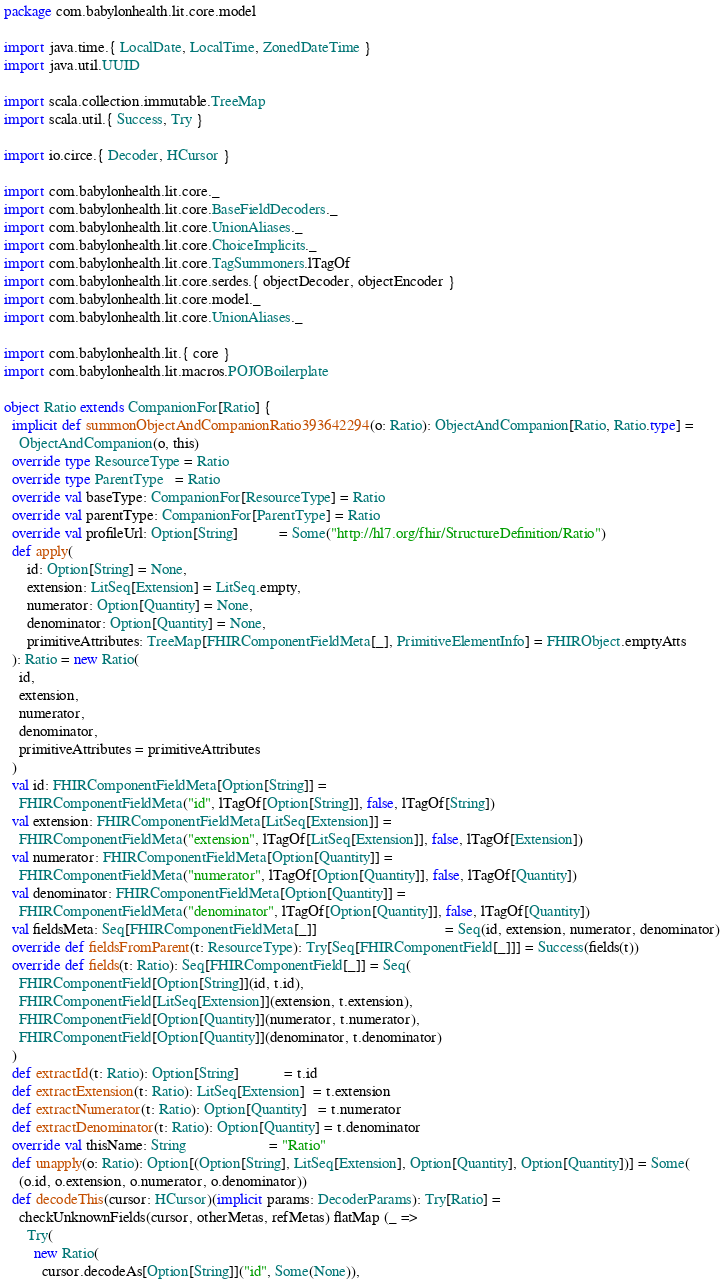Convert code to text. <code><loc_0><loc_0><loc_500><loc_500><_Scala_>package com.babylonhealth.lit.core.model

import java.time.{ LocalDate, LocalTime, ZonedDateTime }
import java.util.UUID

import scala.collection.immutable.TreeMap
import scala.util.{ Success, Try }

import io.circe.{ Decoder, HCursor }

import com.babylonhealth.lit.core._
import com.babylonhealth.lit.core.BaseFieldDecoders._
import com.babylonhealth.lit.core.UnionAliases._
import com.babylonhealth.lit.core.ChoiceImplicits._
import com.babylonhealth.lit.core.TagSummoners.lTagOf
import com.babylonhealth.lit.core.serdes.{ objectDecoder, objectEncoder }
import com.babylonhealth.lit.core.model._
import com.babylonhealth.lit.core.UnionAliases._

import com.babylonhealth.lit.{ core }
import com.babylonhealth.lit.macros.POJOBoilerplate

object Ratio extends CompanionFor[Ratio] {
  implicit def summonObjectAndCompanionRatio393642294(o: Ratio): ObjectAndCompanion[Ratio, Ratio.type] =
    ObjectAndCompanion(o, this)
  override type ResourceType = Ratio
  override type ParentType   = Ratio
  override val baseType: CompanionFor[ResourceType] = Ratio
  override val parentType: CompanionFor[ParentType] = Ratio
  override val profileUrl: Option[String]           = Some("http://hl7.org/fhir/StructureDefinition/Ratio")
  def apply(
      id: Option[String] = None,
      extension: LitSeq[Extension] = LitSeq.empty,
      numerator: Option[Quantity] = None,
      denominator: Option[Quantity] = None,
      primitiveAttributes: TreeMap[FHIRComponentFieldMeta[_], PrimitiveElementInfo] = FHIRObject.emptyAtts
  ): Ratio = new Ratio(
    id,
    extension,
    numerator,
    denominator,
    primitiveAttributes = primitiveAttributes
  )
  val id: FHIRComponentFieldMeta[Option[String]] =
    FHIRComponentFieldMeta("id", lTagOf[Option[String]], false, lTagOf[String])
  val extension: FHIRComponentFieldMeta[LitSeq[Extension]] =
    FHIRComponentFieldMeta("extension", lTagOf[LitSeq[Extension]], false, lTagOf[Extension])
  val numerator: FHIRComponentFieldMeta[Option[Quantity]] =
    FHIRComponentFieldMeta("numerator", lTagOf[Option[Quantity]], false, lTagOf[Quantity])
  val denominator: FHIRComponentFieldMeta[Option[Quantity]] =
    FHIRComponentFieldMeta("denominator", lTagOf[Option[Quantity]], false, lTagOf[Quantity])
  val fieldsMeta: Seq[FHIRComponentFieldMeta[_]]                                  = Seq(id, extension, numerator, denominator)
  override def fieldsFromParent(t: ResourceType): Try[Seq[FHIRComponentField[_]]] = Success(fields(t))
  override def fields(t: Ratio): Seq[FHIRComponentField[_]] = Seq(
    FHIRComponentField[Option[String]](id, t.id),
    FHIRComponentField[LitSeq[Extension]](extension, t.extension),
    FHIRComponentField[Option[Quantity]](numerator, t.numerator),
    FHIRComponentField[Option[Quantity]](denominator, t.denominator)
  )
  def extractId(t: Ratio): Option[String]            = t.id
  def extractExtension(t: Ratio): LitSeq[Extension]  = t.extension
  def extractNumerator(t: Ratio): Option[Quantity]   = t.numerator
  def extractDenominator(t: Ratio): Option[Quantity] = t.denominator
  override val thisName: String                      = "Ratio"
  def unapply(o: Ratio): Option[(Option[String], LitSeq[Extension], Option[Quantity], Option[Quantity])] = Some(
    (o.id, o.extension, o.numerator, o.denominator))
  def decodeThis(cursor: HCursor)(implicit params: DecoderParams): Try[Ratio] =
    checkUnknownFields(cursor, otherMetas, refMetas) flatMap (_ =>
      Try(
        new Ratio(
          cursor.decodeAs[Option[String]]("id", Some(None)),</code> 